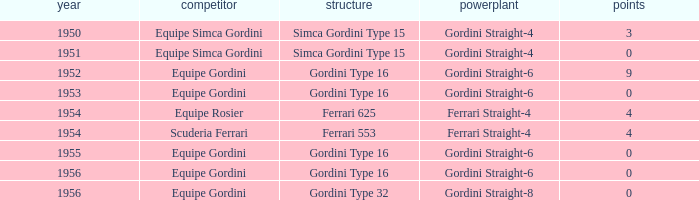What engine was used by Equipe Simca Gordini before 1956 with less than 4 points? Gordini Straight-4, Gordini Straight-4. 